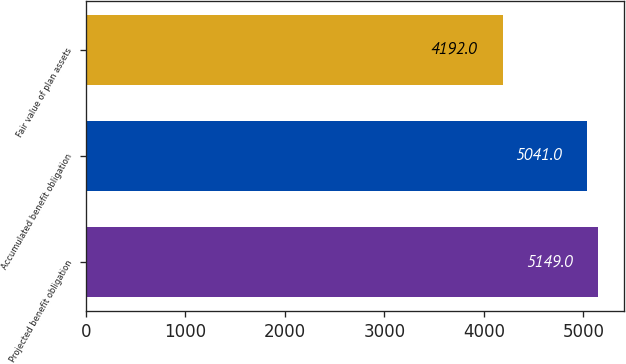Convert chart to OTSL. <chart><loc_0><loc_0><loc_500><loc_500><bar_chart><fcel>Projected benefit obligation<fcel>Accumulated benefit obligation<fcel>Fair value of plan assets<nl><fcel>5149<fcel>5041<fcel>4192<nl></chart> 